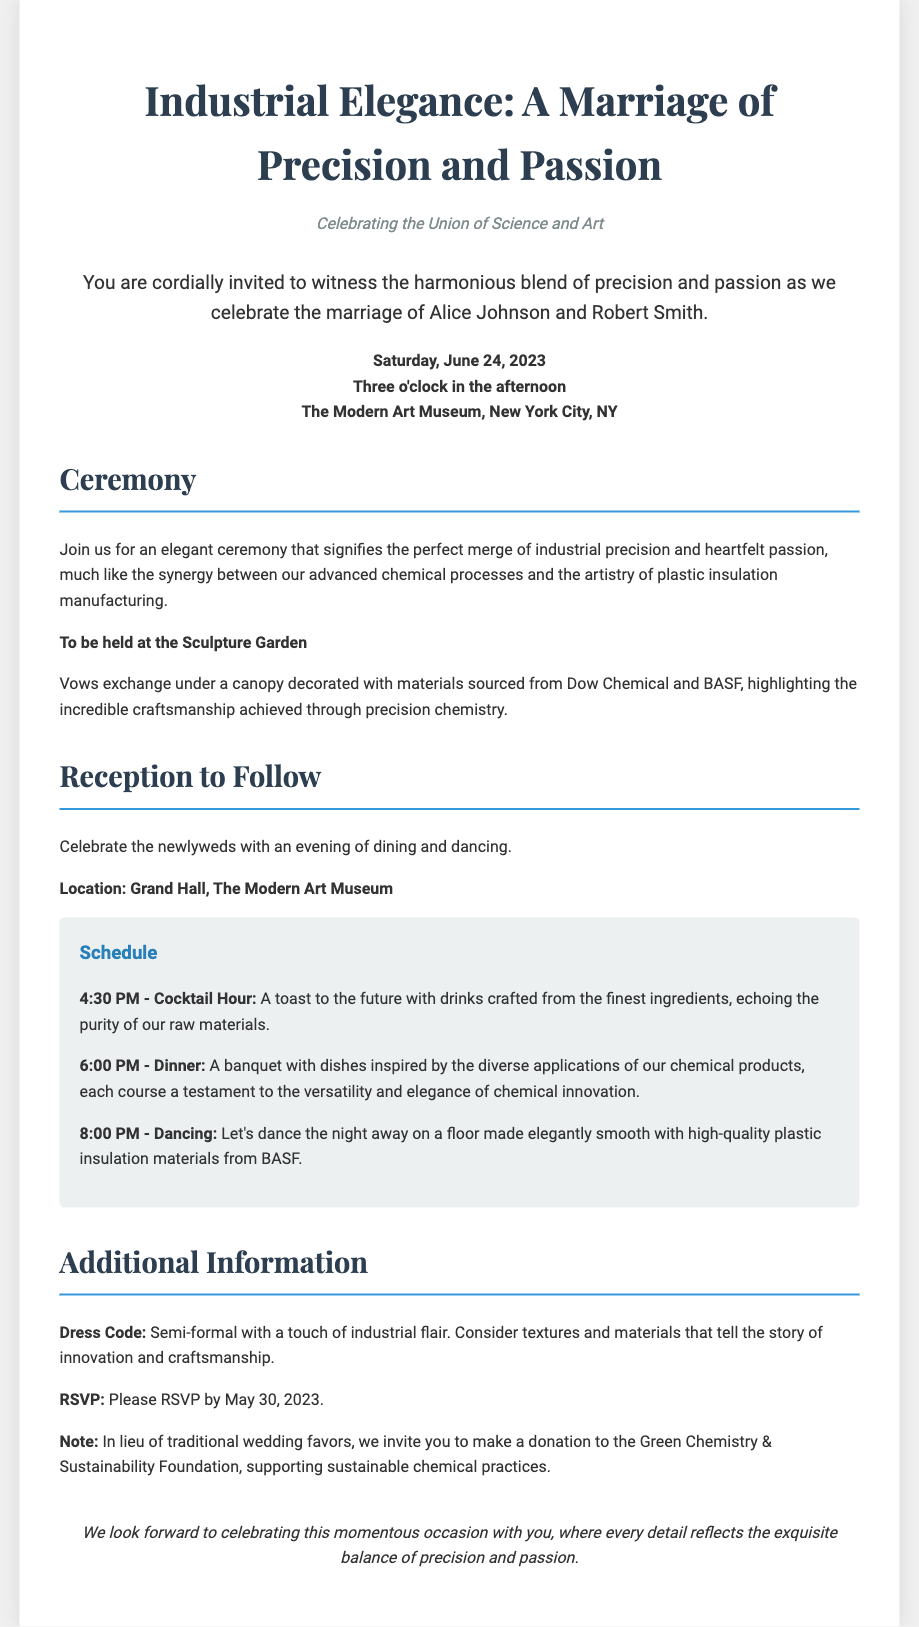What is the name of the bride? The bride's name is mentioned in the greeting section of the document.
Answer: Alice Johnson What is the date of the wedding? The date is specified in the date-time-location section of the document.
Answer: June 24, 2023 Where is the ceremony taking place? The location of the ceremony is detailed in the ceremony section.
Answer: Sculpture Garden What time does the cocktail hour begin? The schedule in the reception section provides the start time for the cocktail hour.
Answer: 4:30 PM What is requested instead of traditional wedding favors? The additional information section specifies what the couple prefers instead of favors.
Answer: A donation How would you describe the dress code? The additional information section describes the dress code for the event.
Answer: Semi-formal with a touch of industrial flair What is the main theme of the wedding invitation? The title and subtitle give insight into the overall theme of the invitation.
Answer: Industrial Elegance What is the name of the groom? The groom's name is also mentioned in the greeting section.
Answer: Robert Smith What is the location of the reception? The reception information includes the specific location at the venue.
Answer: Grand Hall, The Modern Art Museum 